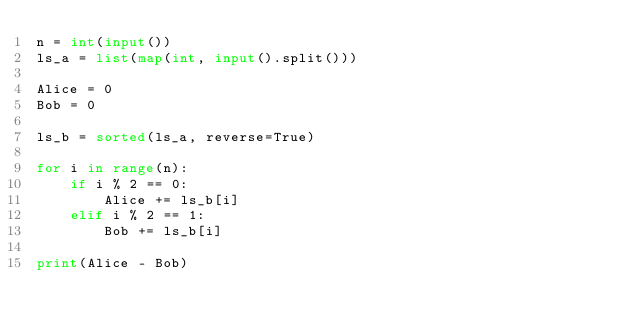Convert code to text. <code><loc_0><loc_0><loc_500><loc_500><_Python_>n = int(input())
ls_a = list(map(int, input().split()))

Alice = 0
Bob = 0

ls_b = sorted(ls_a, reverse=True)

for i in range(n):
    if i % 2 == 0:
        Alice += ls_b[i]
    elif i % 2 == 1:
        Bob += ls_b[i]

print(Alice - Bob)</code> 